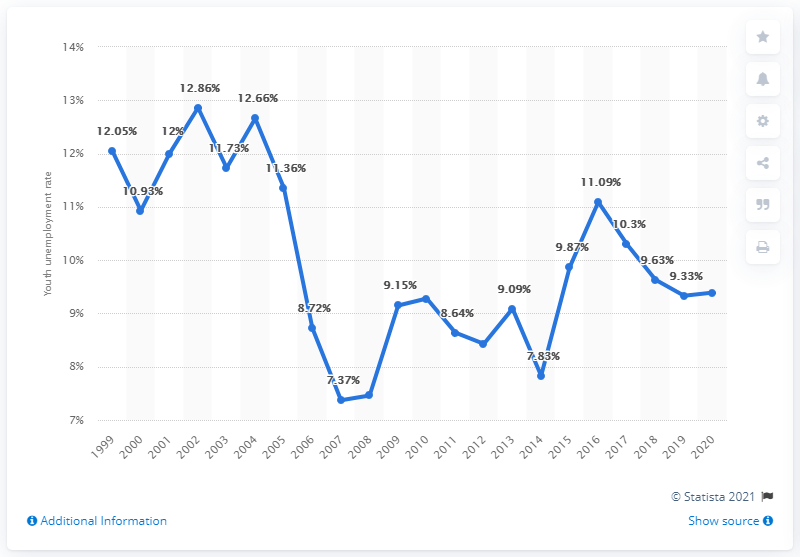What was the youth unemployment rate in Norway in 2020? In 2020, the youth unemployment rate in Norway was 9.39%, indicating the percentage of the labor force aged 15-24 without work but available for and seeking employment. 